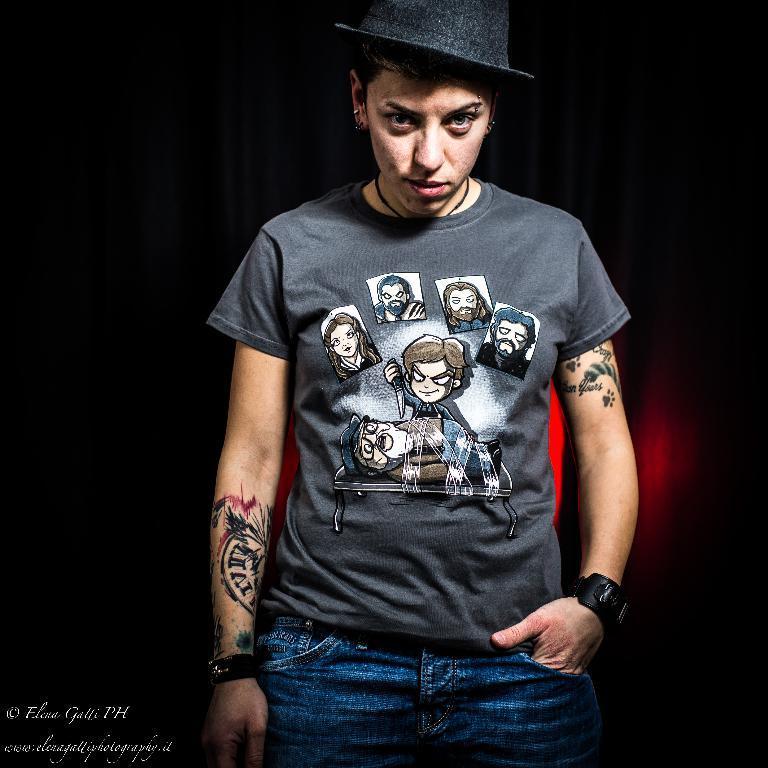In one or two sentences, can you explain what this image depicts? In this image, in the middle, we can see a person wearing a black color hat is standing. In the background, we can see black color and red color. 